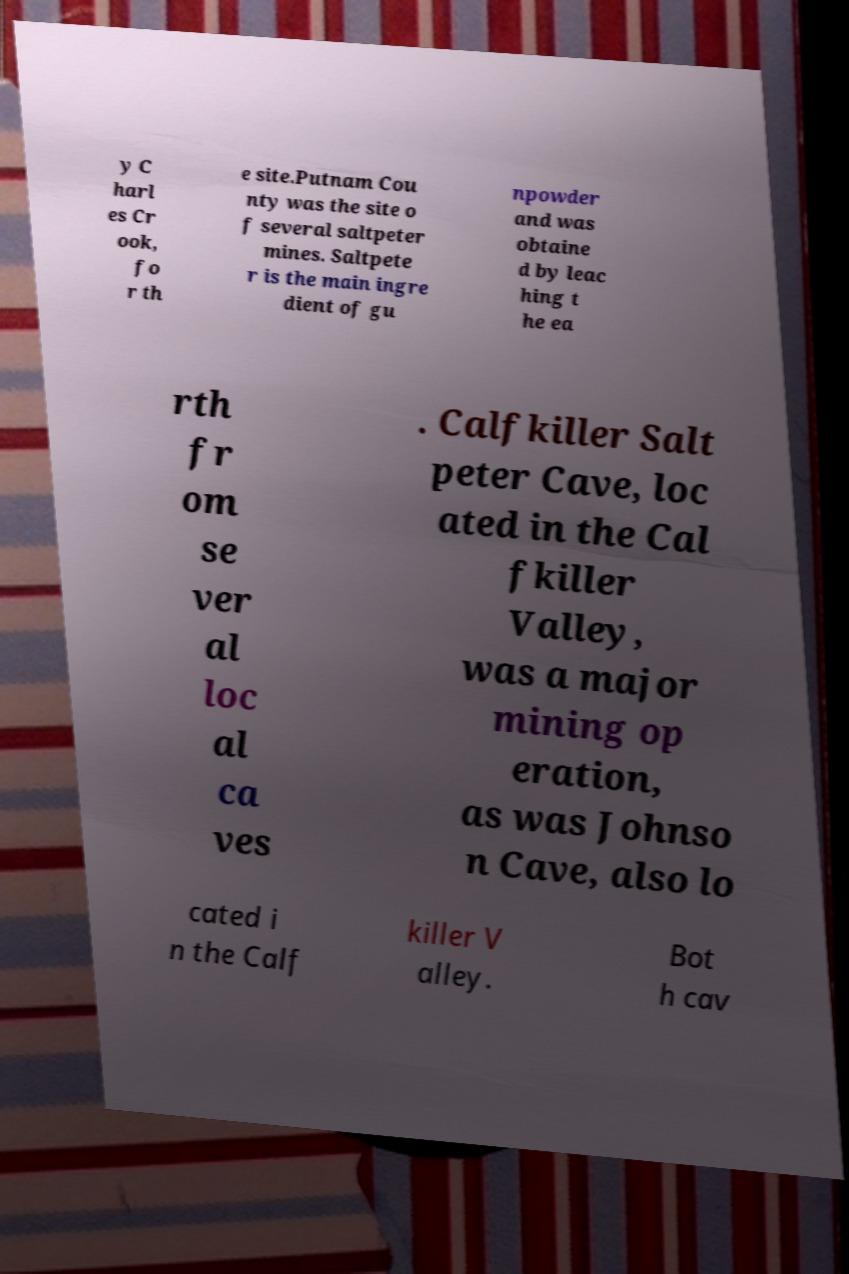There's text embedded in this image that I need extracted. Can you transcribe it verbatim? y C harl es Cr ook, fo r th e site.Putnam Cou nty was the site o f several saltpeter mines. Saltpete r is the main ingre dient of gu npowder and was obtaine d by leac hing t he ea rth fr om se ver al loc al ca ves . Calfkiller Salt peter Cave, loc ated in the Cal fkiller Valley, was a major mining op eration, as was Johnso n Cave, also lo cated i n the Calf killer V alley. Bot h cav 